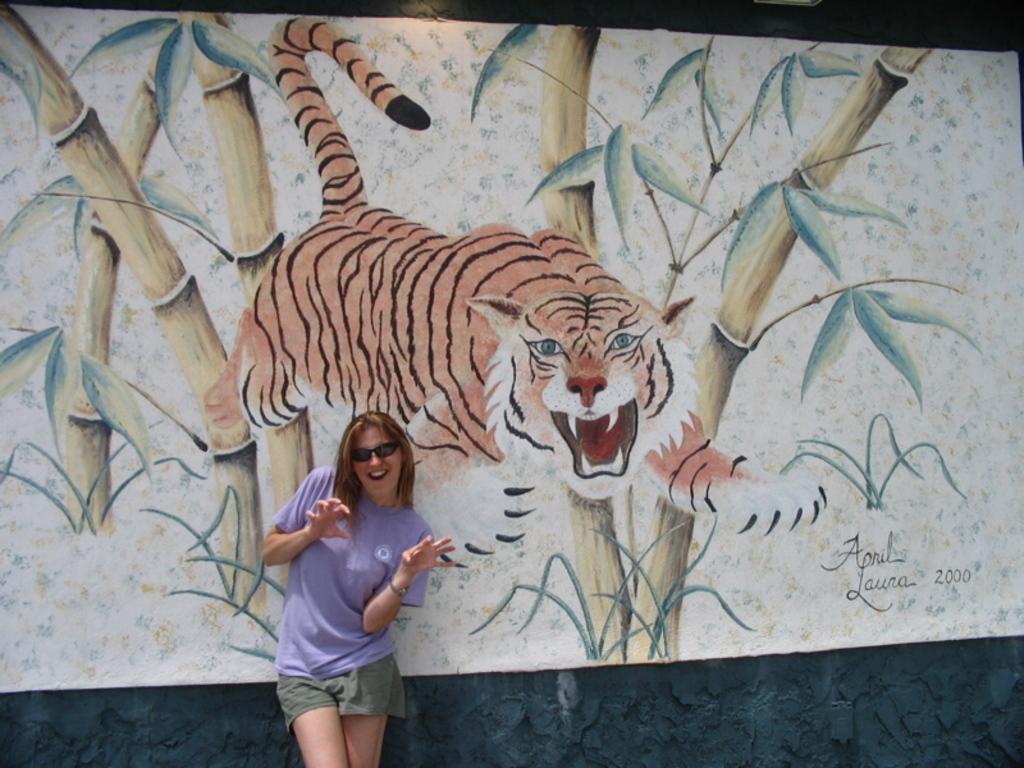Describe this image in one or two sentences. In this image we can see a woman wearing the glasses and standing. In the background we can see the painting board and also the wall. We can also see the text on the board. 